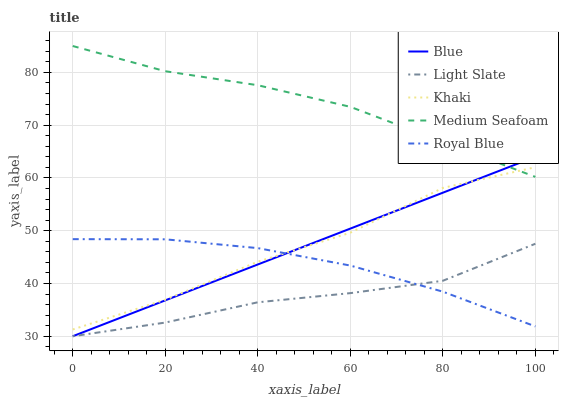Does Light Slate have the minimum area under the curve?
Answer yes or no. Yes. Does Medium Seafoam have the maximum area under the curve?
Answer yes or no. Yes. Does Khaki have the minimum area under the curve?
Answer yes or no. No. Does Khaki have the maximum area under the curve?
Answer yes or no. No. Is Blue the smoothest?
Answer yes or no. Yes. Is Khaki the roughest?
Answer yes or no. Yes. Is Light Slate the smoothest?
Answer yes or no. No. Is Light Slate the roughest?
Answer yes or no. No. Does Blue have the lowest value?
Answer yes or no. Yes. Does Khaki have the lowest value?
Answer yes or no. No. Does Medium Seafoam have the highest value?
Answer yes or no. Yes. Does Khaki have the highest value?
Answer yes or no. No. Is Light Slate less than Medium Seafoam?
Answer yes or no. Yes. Is Khaki greater than Light Slate?
Answer yes or no. Yes. Does Khaki intersect Medium Seafoam?
Answer yes or no. Yes. Is Khaki less than Medium Seafoam?
Answer yes or no. No. Is Khaki greater than Medium Seafoam?
Answer yes or no. No. Does Light Slate intersect Medium Seafoam?
Answer yes or no. No. 